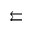Convert formula to latex. <formula><loc_0><loc_0><loc_500><loc_500>\left l e f t a r r o w s</formula> 